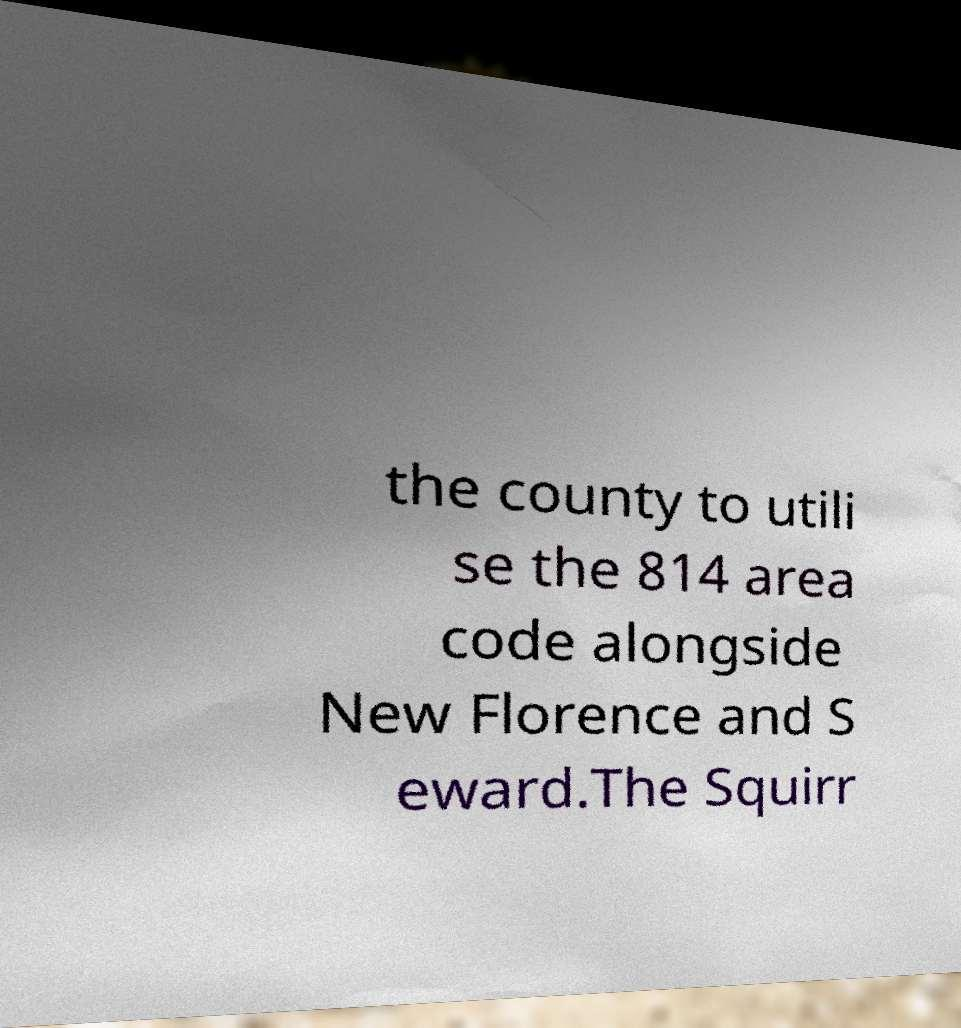Please identify and transcribe the text found in this image. the county to utili se the 814 area code alongside New Florence and S eward.The Squirr 